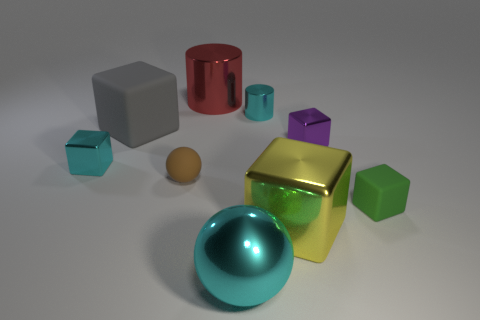What number of other objects have the same shape as the brown object?
Provide a succinct answer. 1. Is the number of cylinders that are to the right of the large cyan thing greater than the number of small red shiny things?
Make the answer very short. Yes. What is the shape of the small object that is to the right of the large yellow metal object and in front of the cyan cube?
Your answer should be compact. Cube. Is the green object the same size as the gray matte cube?
Offer a terse response. No. There is a cyan ball; what number of big yellow shiny objects are in front of it?
Provide a short and direct response. 0. Are there the same number of cyan shiny things that are on the left side of the big gray matte cube and purple metallic cubes that are in front of the big cylinder?
Your answer should be compact. Yes. There is a cyan shiny object to the left of the large metal sphere; does it have the same shape as the tiny brown matte object?
Offer a very short reply. No. Do the matte sphere and the rubber cube that is left of the red cylinder have the same size?
Offer a terse response. No. What number of other things are there of the same color as the tiny sphere?
Ensure brevity in your answer.  0. There is a tiny cyan shiny block; are there any tiny metal objects behind it?
Make the answer very short. Yes. 